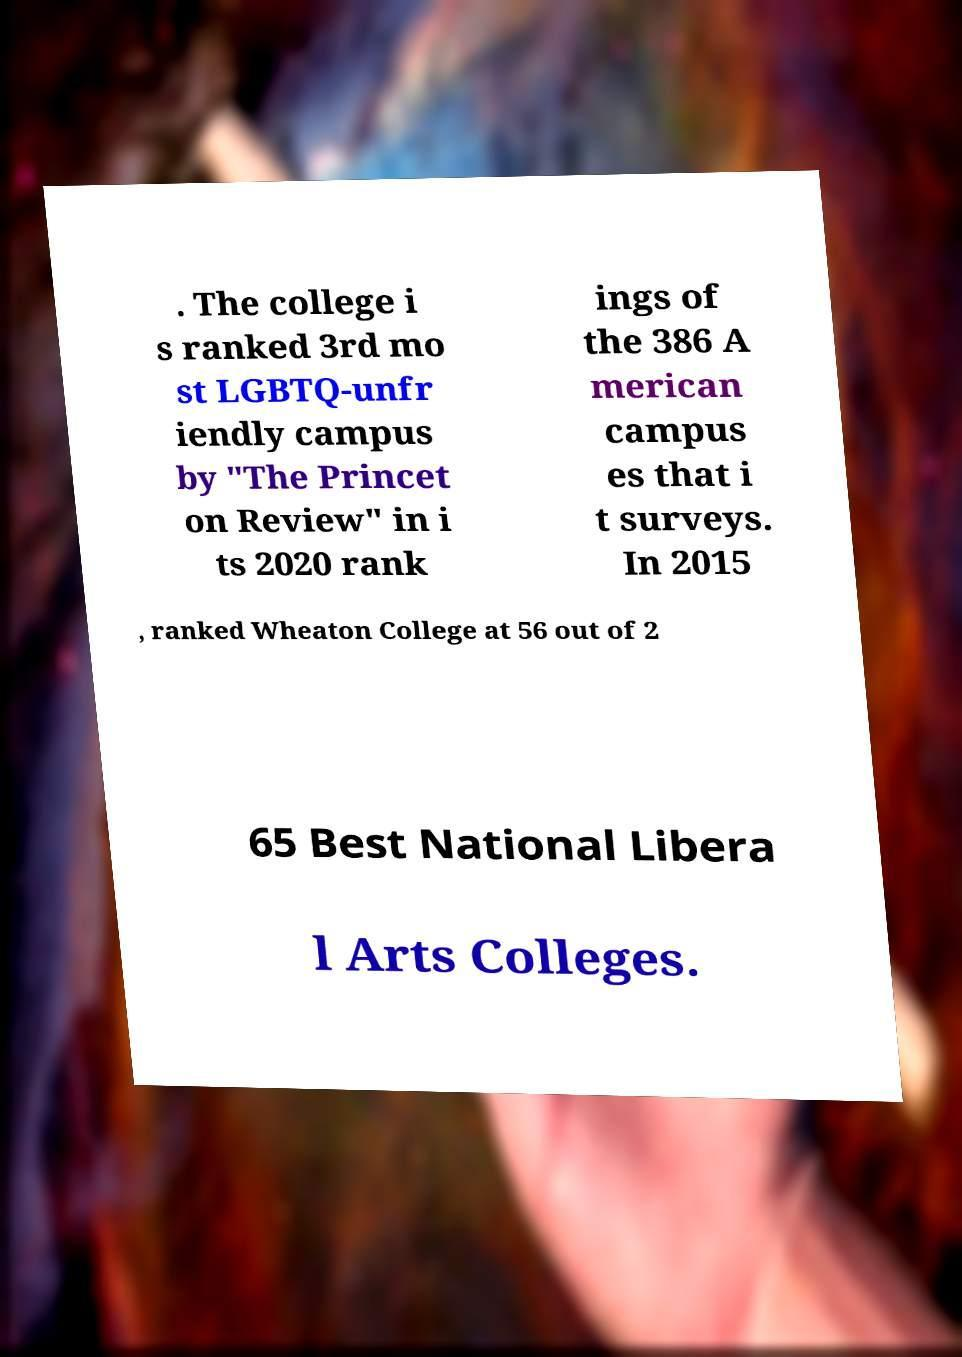Please identify and transcribe the text found in this image. . The college i s ranked 3rd mo st LGBTQ-unfr iendly campus by "The Princet on Review" in i ts 2020 rank ings of the 386 A merican campus es that i t surveys. In 2015 , ranked Wheaton College at 56 out of 2 65 Best National Libera l Arts Colleges. 